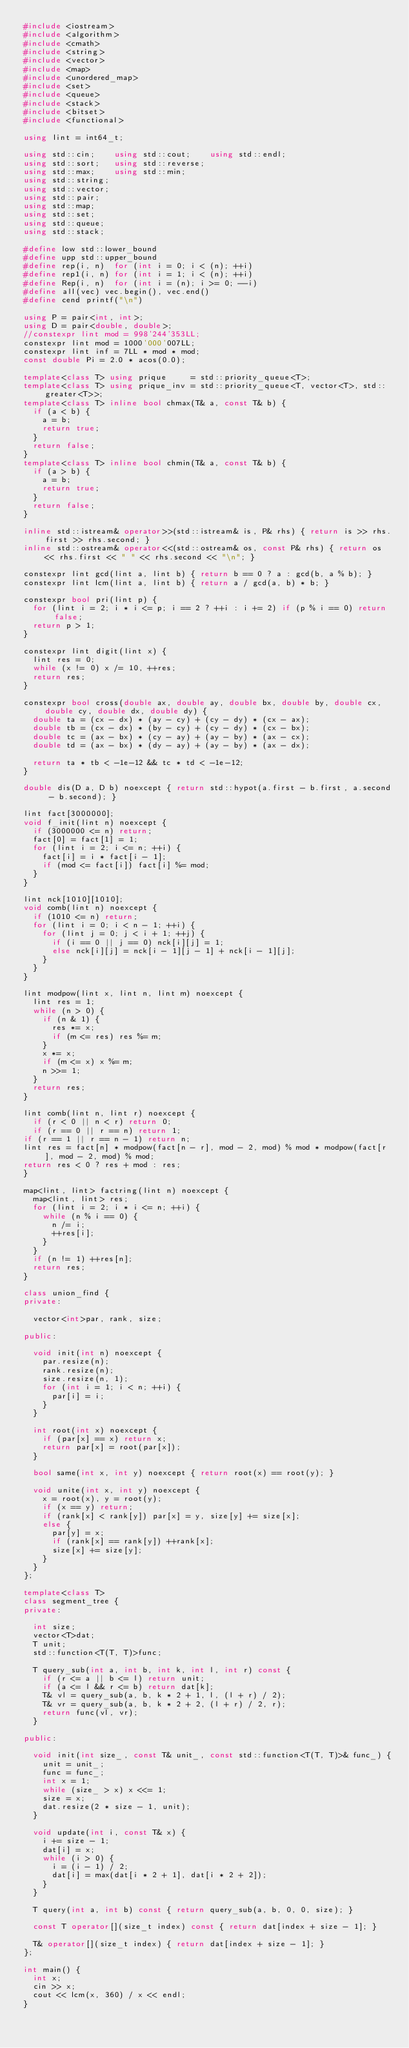<code> <loc_0><loc_0><loc_500><loc_500><_C++_>#include <iostream>
#include <algorithm>
#include <cmath>
#include <string>
#include <vector>
#include <map>
#include <unordered_map>
#include <set>
#include <queue>
#include <stack>
#include <bitset>
#include <functional>

using lint = int64_t;

using std::cin;    using std::cout;    using std::endl;
using std::sort;   using std::reverse;
using std::max;    using std::min;
using std::string;
using std::vector;
using std::pair;
using std::map;
using std::set;
using std::queue;
using std::stack;

#define low std::lower_bound
#define upp std::upper_bound
#define rep(i, n)  for (int i = 0; i < (n); ++i)
#define rep1(i, n) for (int i = 1; i < (n); ++i)
#define Rep(i, n)  for (int i = (n); i >= 0; --i)
#define all(vec) vec.begin(), vec.end()
#define cend printf("\n")

using P = pair<int, int>;
using D = pair<double, double>;
//constexpr lint mod = 998'244'353LL;
constexpr lint mod = 1000'000'007LL;
constexpr lint inf = 7LL * mod * mod;
const double Pi = 2.0 * acos(0.0);

template<class T> using prique     = std::priority_queue<T>;
template<class T> using prique_inv = std::priority_queue<T, vector<T>, std::greater<T>>;
template<class T> inline bool chmax(T& a, const T& b) {
	if (a < b) {
		a = b;
		return true;
	}
	return false;
}
template<class T> inline bool chmin(T& a, const T& b) {
	if (a > b) {
		a = b;
		return true;
	}
	return false;
}

inline std::istream& operator>>(std::istream& is, P& rhs) { return is >> rhs.first >> rhs.second; }
inline std::ostream& operator<<(std::ostream& os, const P& rhs) { return os << rhs.first << " " << rhs.second << "\n"; }

constexpr lint gcd(lint a, lint b) { return b == 0 ? a : gcd(b, a % b); }
constexpr lint lcm(lint a, lint b) { return a / gcd(a, b) * b; }

constexpr bool pri(lint p) {
	for (lint i = 2; i * i <= p; i == 2 ? ++i : i += 2) if (p % i == 0) return false;
	return p > 1;
}

constexpr lint digit(lint x) {
	lint res = 0;
	while (x != 0) x /= 10, ++res;
	return res;
}

constexpr bool cross(double ax, double ay, double bx, double by, double cx, double cy, double dx, double dy) {
	double ta = (cx - dx) * (ay - cy) + (cy - dy) * (cx - ax);
	double tb = (cx - dx) * (by - cy) + (cy - dy) * (cx - bx);
	double tc = (ax - bx) * (cy - ay) + (ay - by) * (ax - cx);
	double td = (ax - bx) * (dy - ay) + (ay - by) * (ax - dx);

	return ta * tb < -1e-12 && tc * td < -1e-12;
}

double dis(D a, D b) noexcept { return std::hypot(a.first - b.first, a.second - b.second); }

lint fact[3000000];
void f_init(lint n) noexcept {
	if (3000000 <= n) return;
	fact[0] = fact[1] = 1;
	for (lint i = 2; i <= n; ++i) {
		fact[i] = i * fact[i - 1];
		if (mod <= fact[i]) fact[i] %= mod;
	}
}

lint nck[1010][1010];
void comb(lint n) noexcept {
	if (1010 <= n) return;
	for (lint i = 0; i < n - 1; ++i) {
		for (lint j = 0; j < i + 1; ++j) {
			if (i == 0 || j == 0) nck[i][j] = 1;
			else nck[i][j] = nck[i - 1][j - 1] + nck[i - 1][j];
		}
	}
}

lint modpow(lint x, lint n, lint m) noexcept {
	lint res = 1;
	while (n > 0) {
		if (n & 1) {
			res *= x;
			if (m <= res) res %= m;
		}
		x *= x;
		if (m <= x) x %= m;
		n >>= 1;
	}
	return res;
}

lint comb(lint n, lint r) noexcept {
	if (r < 0 || n < r) return 0;
	if (r == 0 || r == n) return 1;
if (r == 1 || r == n - 1) return n;
lint res = fact[n] * modpow(fact[n - r], mod - 2, mod) % mod * modpow(fact[r], mod - 2, mod) % mod;
return res < 0 ? res + mod : res;
}

map<lint, lint> factring(lint n) noexcept {
	map<lint, lint> res;
	for (lint i = 2; i * i <= n; ++i) {
		while (n % i == 0) {
			n /= i;
			++res[i];
		}
	}
	if (n != 1) ++res[n];
	return res;
}

class union_find {
private:

	vector<int>par, rank, size;

public:

	void init(int n) noexcept {
		par.resize(n);
		rank.resize(n);
		size.resize(n, 1);
		for (int i = 1; i < n; ++i) {
			par[i] = i;
		}
	}

	int root(int x) noexcept {
		if (par[x] == x) return x;
		return par[x] = root(par[x]);
	}

	bool same(int x, int y) noexcept { return root(x) == root(y); }

	void unite(int x, int y) noexcept {
		x = root(x), y = root(y);
		if (x == y) return;
		if (rank[x] < rank[y]) par[x] = y, size[y] += size[x];
		else {
			par[y] = x;
			if (rank[x] == rank[y]) ++rank[x];
			size[x] += size[y];
		}
	}
};

template<class T>
class segment_tree {
private:

	int size;
	vector<T>dat;
	T unit;
	std::function<T(T, T)>func;

	T query_sub(int a, int b, int k, int l, int r) const {
		if (r <= a || b <= l) return unit;
		if (a <= l && r <= b) return dat[k];
		T& vl = query_sub(a, b, k * 2 + 1, l, (l + r) / 2);
		T& vr = query_sub(a, b, k * 2 + 2, (l + r) / 2, r);
		return func(vl, vr);
	}

public:

	void init(int size_, const T& unit_, const std::function<T(T, T)>& func_) {
		unit = unit_;
		func = func_;
		int x = 1;
		while (size_ > x) x <<= 1;
		size = x;
		dat.resize(2 * size - 1, unit);
	}

	void update(int i, const T& x) {
		i += size - 1;
		dat[i] = x;
		while (i > 0) {
			i = (i - 1) / 2;
			dat[i] = max(dat[i * 2 + 1], dat[i * 2 + 2]);
		}
	}

	T query(int a, int b) const { return query_sub(a, b, 0, 0, size); }

	const T operator[](size_t index) const { return dat[index + size - 1]; }

	T& operator[](size_t index) { return dat[index + size - 1]; }
};

int main() {
	int x;
	cin >> x;
	cout << lcm(x, 360) / x << endl;
}</code> 